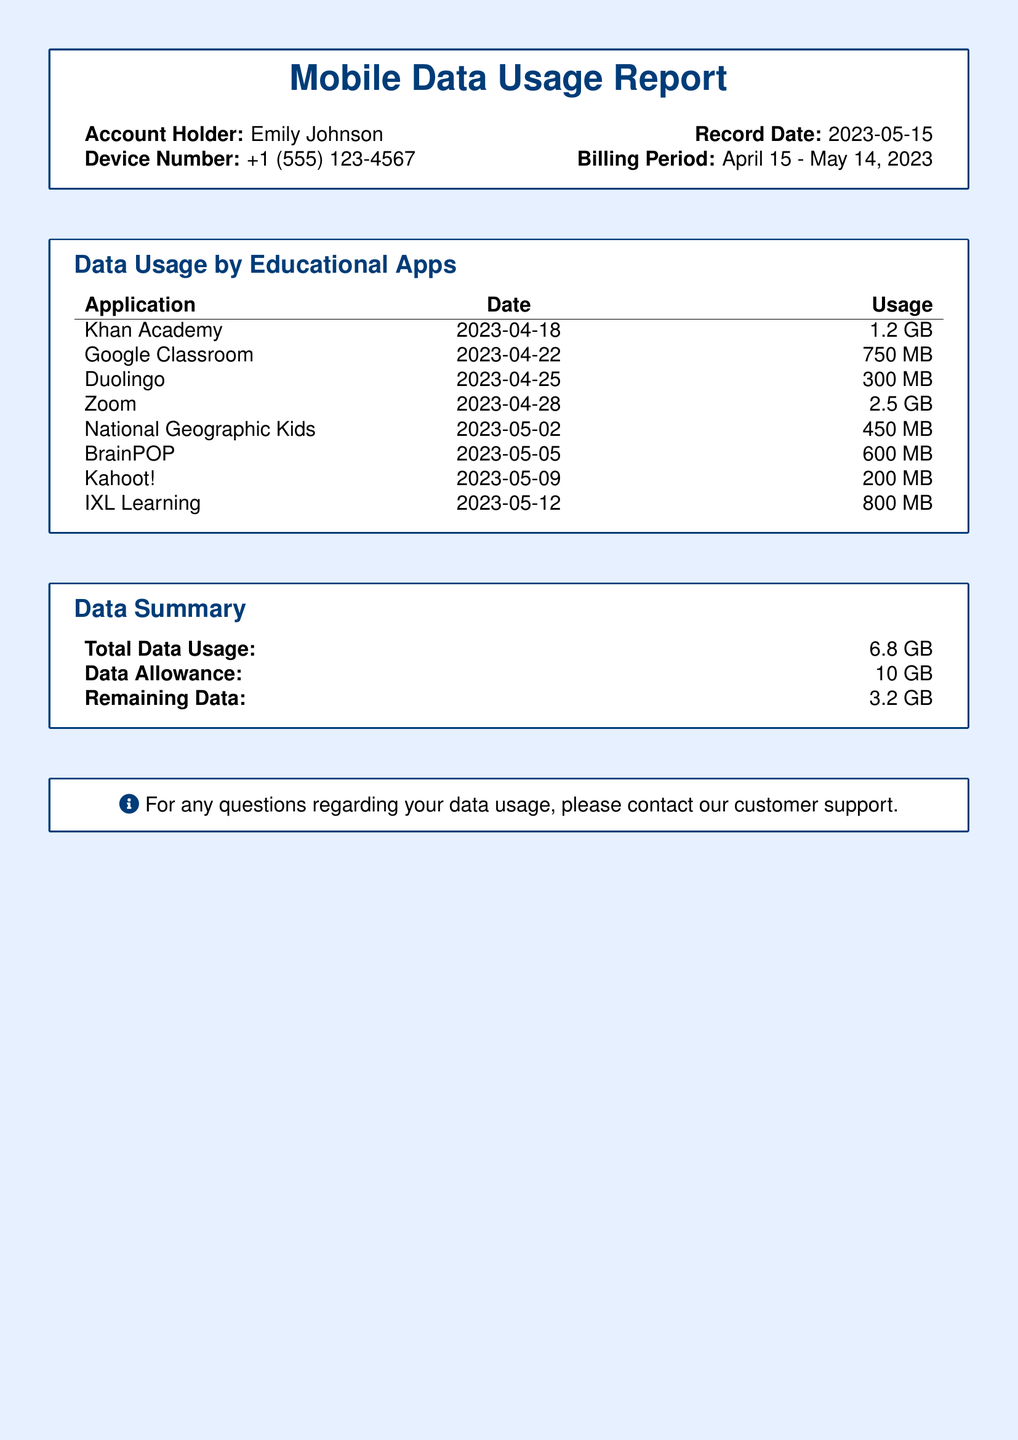What is the account holder's name? The account holder's name is listed at the top of the document.
Answer: Emily Johnson How much data was used by Zoom? The data used by Zoom is mentioned in the data usage table.
Answer: 2.5 GB What is the total data usage? The total data usage is summarized at the end of the document.
Answer: 6.8 GB On what date was the Khan Academy app used? The date is specified in the data usage table for the Khan Academy app.
Answer: 2023-04-18 What is the remaining data allowance? The remaining data is provided in the data summary section of the document.
Answer: 3.2 GB Which educational app consumed the least amount of data? The data usage table lists all apps with their corresponding data usage.
Answer: Kahoot! How many apps are listed in the data usage section? The number of apps is determined by counting the entries in the data usage table.
Answer: 8 What is the data allowance for the billing period? The data allowance is provided in the summary of the document.
Answer: 10 GB 